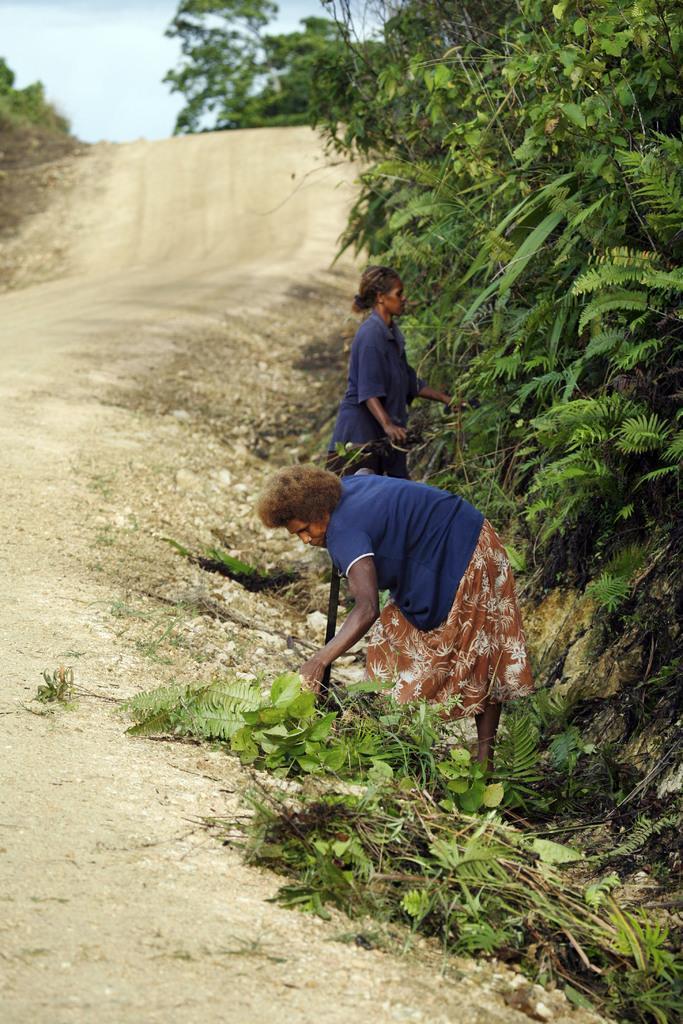Please provide a concise description of this image. In this picture there are two ladies in the center of the image and there are trees on the right side of the image, there is path on the left side of the image. 